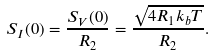<formula> <loc_0><loc_0><loc_500><loc_500>S _ { I } ( 0 ) = \frac { S _ { V } ( 0 ) } { R _ { 2 } } = \frac { \sqrt { 4 R _ { 1 } k _ { b } T } } { R _ { 2 } } .</formula> 